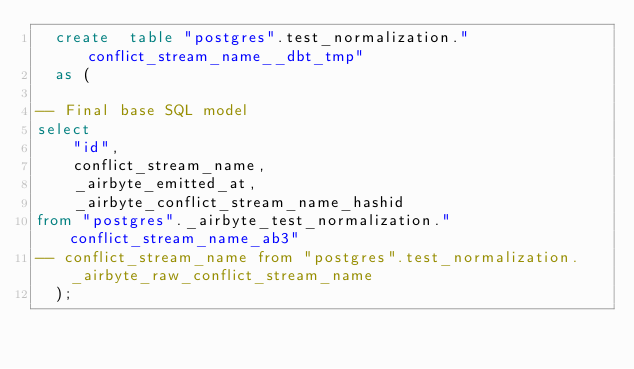Convert code to text. <code><loc_0><loc_0><loc_500><loc_500><_SQL_>  create  table "postgres".test_normalization."conflict_stream_name__dbt_tmp"
  as (
    
-- Final base SQL model
select
    "id",
    conflict_stream_name,
    _airbyte_emitted_at,
    _airbyte_conflict_stream_name_hashid
from "postgres"._airbyte_test_normalization."conflict_stream_name_ab3"
-- conflict_stream_name from "postgres".test_normalization._airbyte_raw_conflict_stream_name
  );</code> 